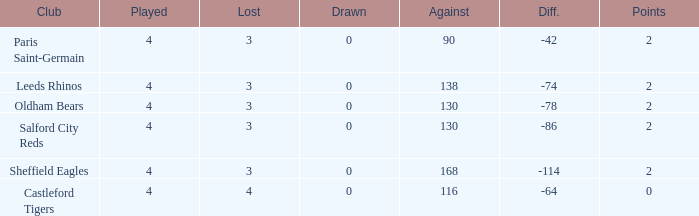What is the total of losses for teams with fewer than 4 games played? None. 